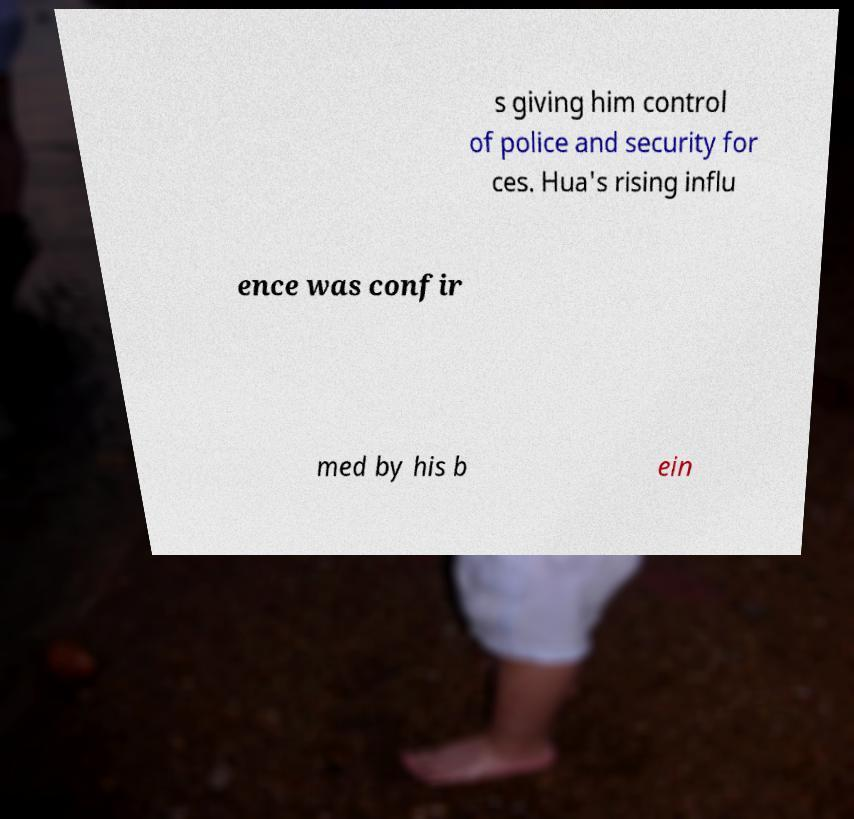There's text embedded in this image that I need extracted. Can you transcribe it verbatim? s giving him control of police and security for ces. Hua's rising influ ence was confir med by his b ein 